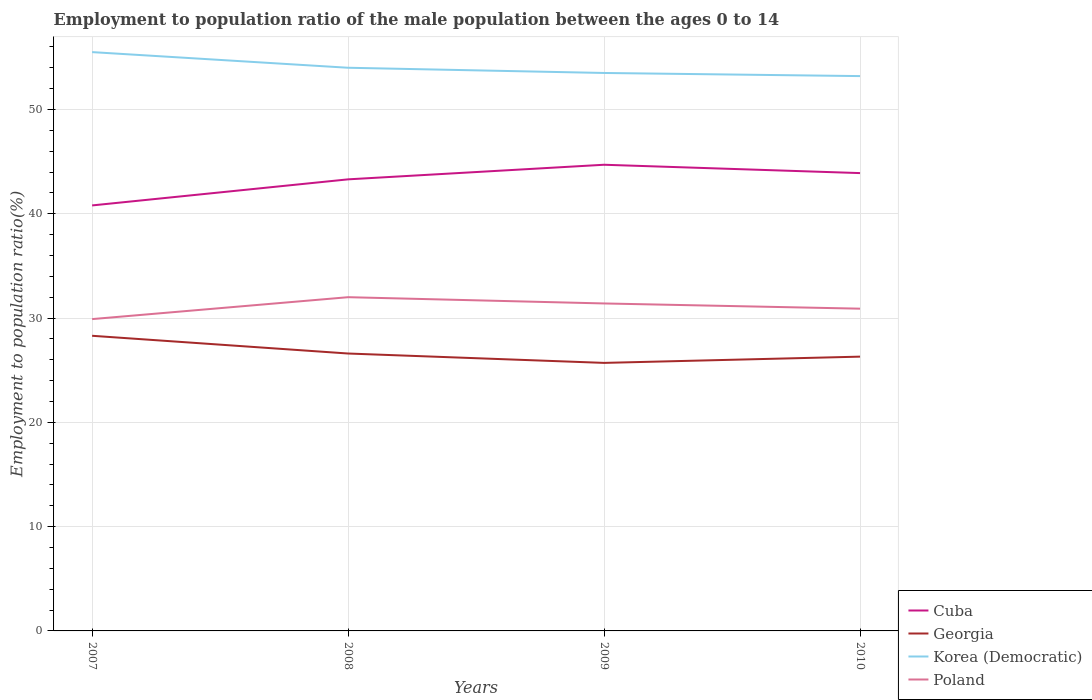How many different coloured lines are there?
Your answer should be very brief. 4. Across all years, what is the maximum employment to population ratio in Korea (Democratic)?
Provide a short and direct response. 53.2. What is the difference between the highest and the second highest employment to population ratio in Cuba?
Provide a short and direct response. 3.9. Are the values on the major ticks of Y-axis written in scientific E-notation?
Provide a short and direct response. No. Does the graph contain any zero values?
Your answer should be very brief. No. Does the graph contain grids?
Provide a short and direct response. Yes. Where does the legend appear in the graph?
Provide a short and direct response. Bottom right. How are the legend labels stacked?
Make the answer very short. Vertical. What is the title of the graph?
Make the answer very short. Employment to population ratio of the male population between the ages 0 to 14. What is the Employment to population ratio(%) in Cuba in 2007?
Offer a very short reply. 40.8. What is the Employment to population ratio(%) of Georgia in 2007?
Make the answer very short. 28.3. What is the Employment to population ratio(%) of Korea (Democratic) in 2007?
Your answer should be very brief. 55.5. What is the Employment to population ratio(%) of Poland in 2007?
Your answer should be compact. 29.9. What is the Employment to population ratio(%) of Cuba in 2008?
Your answer should be compact. 43.3. What is the Employment to population ratio(%) of Georgia in 2008?
Keep it short and to the point. 26.6. What is the Employment to population ratio(%) in Cuba in 2009?
Keep it short and to the point. 44.7. What is the Employment to population ratio(%) of Georgia in 2009?
Make the answer very short. 25.7. What is the Employment to population ratio(%) in Korea (Democratic) in 2009?
Your answer should be compact. 53.5. What is the Employment to population ratio(%) of Poland in 2009?
Make the answer very short. 31.4. What is the Employment to population ratio(%) of Cuba in 2010?
Make the answer very short. 43.9. What is the Employment to population ratio(%) of Georgia in 2010?
Offer a terse response. 26.3. What is the Employment to population ratio(%) in Korea (Democratic) in 2010?
Provide a short and direct response. 53.2. What is the Employment to population ratio(%) of Poland in 2010?
Keep it short and to the point. 30.9. Across all years, what is the maximum Employment to population ratio(%) in Cuba?
Your response must be concise. 44.7. Across all years, what is the maximum Employment to population ratio(%) of Georgia?
Your response must be concise. 28.3. Across all years, what is the maximum Employment to population ratio(%) of Korea (Democratic)?
Keep it short and to the point. 55.5. Across all years, what is the maximum Employment to population ratio(%) of Poland?
Your answer should be compact. 32. Across all years, what is the minimum Employment to population ratio(%) of Cuba?
Provide a succinct answer. 40.8. Across all years, what is the minimum Employment to population ratio(%) of Georgia?
Your answer should be compact. 25.7. Across all years, what is the minimum Employment to population ratio(%) in Korea (Democratic)?
Your response must be concise. 53.2. Across all years, what is the minimum Employment to population ratio(%) in Poland?
Give a very brief answer. 29.9. What is the total Employment to population ratio(%) of Cuba in the graph?
Provide a short and direct response. 172.7. What is the total Employment to population ratio(%) in Georgia in the graph?
Ensure brevity in your answer.  106.9. What is the total Employment to population ratio(%) in Korea (Democratic) in the graph?
Offer a very short reply. 216.2. What is the total Employment to population ratio(%) in Poland in the graph?
Your answer should be compact. 124.2. What is the difference between the Employment to population ratio(%) in Cuba in 2007 and that in 2008?
Offer a terse response. -2.5. What is the difference between the Employment to population ratio(%) in Georgia in 2007 and that in 2008?
Make the answer very short. 1.7. What is the difference between the Employment to population ratio(%) of Georgia in 2007 and that in 2009?
Keep it short and to the point. 2.6. What is the difference between the Employment to population ratio(%) of Poland in 2007 and that in 2009?
Give a very brief answer. -1.5. What is the difference between the Employment to population ratio(%) of Cuba in 2007 and that in 2010?
Keep it short and to the point. -3.1. What is the difference between the Employment to population ratio(%) in Georgia in 2007 and that in 2010?
Your answer should be compact. 2. What is the difference between the Employment to population ratio(%) in Korea (Democratic) in 2007 and that in 2010?
Offer a very short reply. 2.3. What is the difference between the Employment to population ratio(%) in Cuba in 2008 and that in 2009?
Your response must be concise. -1.4. What is the difference between the Employment to population ratio(%) of Georgia in 2008 and that in 2009?
Your answer should be very brief. 0.9. What is the difference between the Employment to population ratio(%) of Korea (Democratic) in 2008 and that in 2009?
Make the answer very short. 0.5. What is the difference between the Employment to population ratio(%) of Cuba in 2008 and that in 2010?
Provide a succinct answer. -0.6. What is the difference between the Employment to population ratio(%) in Georgia in 2008 and that in 2010?
Your response must be concise. 0.3. What is the difference between the Employment to population ratio(%) in Poland in 2008 and that in 2010?
Your answer should be very brief. 1.1. What is the difference between the Employment to population ratio(%) of Cuba in 2009 and that in 2010?
Give a very brief answer. 0.8. What is the difference between the Employment to population ratio(%) in Georgia in 2009 and that in 2010?
Your answer should be very brief. -0.6. What is the difference between the Employment to population ratio(%) in Cuba in 2007 and the Employment to population ratio(%) in Georgia in 2008?
Your answer should be compact. 14.2. What is the difference between the Employment to population ratio(%) in Cuba in 2007 and the Employment to population ratio(%) in Korea (Democratic) in 2008?
Your response must be concise. -13.2. What is the difference between the Employment to population ratio(%) in Georgia in 2007 and the Employment to population ratio(%) in Korea (Democratic) in 2008?
Keep it short and to the point. -25.7. What is the difference between the Employment to population ratio(%) of Georgia in 2007 and the Employment to population ratio(%) of Poland in 2008?
Offer a very short reply. -3.7. What is the difference between the Employment to population ratio(%) in Georgia in 2007 and the Employment to population ratio(%) in Korea (Democratic) in 2009?
Offer a very short reply. -25.2. What is the difference between the Employment to population ratio(%) in Korea (Democratic) in 2007 and the Employment to population ratio(%) in Poland in 2009?
Give a very brief answer. 24.1. What is the difference between the Employment to population ratio(%) of Cuba in 2007 and the Employment to population ratio(%) of Korea (Democratic) in 2010?
Your answer should be very brief. -12.4. What is the difference between the Employment to population ratio(%) of Georgia in 2007 and the Employment to population ratio(%) of Korea (Democratic) in 2010?
Give a very brief answer. -24.9. What is the difference between the Employment to population ratio(%) in Korea (Democratic) in 2007 and the Employment to population ratio(%) in Poland in 2010?
Your answer should be compact. 24.6. What is the difference between the Employment to population ratio(%) in Cuba in 2008 and the Employment to population ratio(%) in Korea (Democratic) in 2009?
Your response must be concise. -10.2. What is the difference between the Employment to population ratio(%) of Georgia in 2008 and the Employment to population ratio(%) of Korea (Democratic) in 2009?
Offer a terse response. -26.9. What is the difference between the Employment to population ratio(%) in Korea (Democratic) in 2008 and the Employment to population ratio(%) in Poland in 2009?
Make the answer very short. 22.6. What is the difference between the Employment to population ratio(%) of Georgia in 2008 and the Employment to population ratio(%) of Korea (Democratic) in 2010?
Give a very brief answer. -26.6. What is the difference between the Employment to population ratio(%) of Georgia in 2008 and the Employment to population ratio(%) of Poland in 2010?
Offer a terse response. -4.3. What is the difference between the Employment to population ratio(%) of Korea (Democratic) in 2008 and the Employment to population ratio(%) of Poland in 2010?
Give a very brief answer. 23.1. What is the difference between the Employment to population ratio(%) of Cuba in 2009 and the Employment to population ratio(%) of Georgia in 2010?
Offer a terse response. 18.4. What is the difference between the Employment to population ratio(%) of Georgia in 2009 and the Employment to population ratio(%) of Korea (Democratic) in 2010?
Provide a succinct answer. -27.5. What is the difference between the Employment to population ratio(%) in Georgia in 2009 and the Employment to population ratio(%) in Poland in 2010?
Your answer should be very brief. -5.2. What is the difference between the Employment to population ratio(%) of Korea (Democratic) in 2009 and the Employment to population ratio(%) of Poland in 2010?
Your answer should be very brief. 22.6. What is the average Employment to population ratio(%) of Cuba per year?
Offer a very short reply. 43.17. What is the average Employment to population ratio(%) of Georgia per year?
Give a very brief answer. 26.73. What is the average Employment to population ratio(%) of Korea (Democratic) per year?
Provide a short and direct response. 54.05. What is the average Employment to population ratio(%) in Poland per year?
Your response must be concise. 31.05. In the year 2007, what is the difference between the Employment to population ratio(%) in Cuba and Employment to population ratio(%) in Korea (Democratic)?
Ensure brevity in your answer.  -14.7. In the year 2007, what is the difference between the Employment to population ratio(%) in Cuba and Employment to population ratio(%) in Poland?
Provide a short and direct response. 10.9. In the year 2007, what is the difference between the Employment to population ratio(%) of Georgia and Employment to population ratio(%) of Korea (Democratic)?
Provide a succinct answer. -27.2. In the year 2007, what is the difference between the Employment to population ratio(%) in Korea (Democratic) and Employment to population ratio(%) in Poland?
Your response must be concise. 25.6. In the year 2008, what is the difference between the Employment to population ratio(%) in Cuba and Employment to population ratio(%) in Korea (Democratic)?
Your answer should be very brief. -10.7. In the year 2008, what is the difference between the Employment to population ratio(%) in Cuba and Employment to population ratio(%) in Poland?
Ensure brevity in your answer.  11.3. In the year 2008, what is the difference between the Employment to population ratio(%) of Georgia and Employment to population ratio(%) of Korea (Democratic)?
Your answer should be compact. -27.4. In the year 2008, what is the difference between the Employment to population ratio(%) in Korea (Democratic) and Employment to population ratio(%) in Poland?
Make the answer very short. 22. In the year 2009, what is the difference between the Employment to population ratio(%) in Cuba and Employment to population ratio(%) in Georgia?
Provide a succinct answer. 19. In the year 2009, what is the difference between the Employment to population ratio(%) of Cuba and Employment to population ratio(%) of Poland?
Offer a terse response. 13.3. In the year 2009, what is the difference between the Employment to population ratio(%) in Georgia and Employment to population ratio(%) in Korea (Democratic)?
Provide a short and direct response. -27.8. In the year 2009, what is the difference between the Employment to population ratio(%) of Georgia and Employment to population ratio(%) of Poland?
Offer a terse response. -5.7. In the year 2009, what is the difference between the Employment to population ratio(%) in Korea (Democratic) and Employment to population ratio(%) in Poland?
Ensure brevity in your answer.  22.1. In the year 2010, what is the difference between the Employment to population ratio(%) of Georgia and Employment to population ratio(%) of Korea (Democratic)?
Offer a very short reply. -26.9. In the year 2010, what is the difference between the Employment to population ratio(%) of Georgia and Employment to population ratio(%) of Poland?
Your answer should be very brief. -4.6. In the year 2010, what is the difference between the Employment to population ratio(%) in Korea (Democratic) and Employment to population ratio(%) in Poland?
Provide a short and direct response. 22.3. What is the ratio of the Employment to population ratio(%) in Cuba in 2007 to that in 2008?
Offer a very short reply. 0.94. What is the ratio of the Employment to population ratio(%) in Georgia in 2007 to that in 2008?
Give a very brief answer. 1.06. What is the ratio of the Employment to population ratio(%) of Korea (Democratic) in 2007 to that in 2008?
Make the answer very short. 1.03. What is the ratio of the Employment to population ratio(%) in Poland in 2007 to that in 2008?
Make the answer very short. 0.93. What is the ratio of the Employment to population ratio(%) of Cuba in 2007 to that in 2009?
Provide a succinct answer. 0.91. What is the ratio of the Employment to population ratio(%) in Georgia in 2007 to that in 2009?
Provide a succinct answer. 1.1. What is the ratio of the Employment to population ratio(%) of Korea (Democratic) in 2007 to that in 2009?
Provide a succinct answer. 1.04. What is the ratio of the Employment to population ratio(%) of Poland in 2007 to that in 2009?
Keep it short and to the point. 0.95. What is the ratio of the Employment to population ratio(%) in Cuba in 2007 to that in 2010?
Ensure brevity in your answer.  0.93. What is the ratio of the Employment to population ratio(%) of Georgia in 2007 to that in 2010?
Offer a very short reply. 1.08. What is the ratio of the Employment to population ratio(%) in Korea (Democratic) in 2007 to that in 2010?
Make the answer very short. 1.04. What is the ratio of the Employment to population ratio(%) in Poland in 2007 to that in 2010?
Provide a succinct answer. 0.97. What is the ratio of the Employment to population ratio(%) in Cuba in 2008 to that in 2009?
Make the answer very short. 0.97. What is the ratio of the Employment to population ratio(%) of Georgia in 2008 to that in 2009?
Give a very brief answer. 1.03. What is the ratio of the Employment to population ratio(%) of Korea (Democratic) in 2008 to that in 2009?
Provide a succinct answer. 1.01. What is the ratio of the Employment to population ratio(%) in Poland in 2008 to that in 2009?
Offer a very short reply. 1.02. What is the ratio of the Employment to population ratio(%) of Cuba in 2008 to that in 2010?
Provide a succinct answer. 0.99. What is the ratio of the Employment to population ratio(%) in Georgia in 2008 to that in 2010?
Ensure brevity in your answer.  1.01. What is the ratio of the Employment to population ratio(%) in Korea (Democratic) in 2008 to that in 2010?
Make the answer very short. 1.01. What is the ratio of the Employment to population ratio(%) of Poland in 2008 to that in 2010?
Your answer should be very brief. 1.04. What is the ratio of the Employment to population ratio(%) in Cuba in 2009 to that in 2010?
Ensure brevity in your answer.  1.02. What is the ratio of the Employment to population ratio(%) in Georgia in 2009 to that in 2010?
Your response must be concise. 0.98. What is the ratio of the Employment to population ratio(%) in Korea (Democratic) in 2009 to that in 2010?
Offer a very short reply. 1.01. What is the ratio of the Employment to population ratio(%) of Poland in 2009 to that in 2010?
Your answer should be very brief. 1.02. What is the difference between the highest and the second highest Employment to population ratio(%) in Georgia?
Your answer should be very brief. 1.7. What is the difference between the highest and the lowest Employment to population ratio(%) in Poland?
Offer a very short reply. 2.1. 